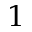<formula> <loc_0><loc_0><loc_500><loc_500>1</formula> 